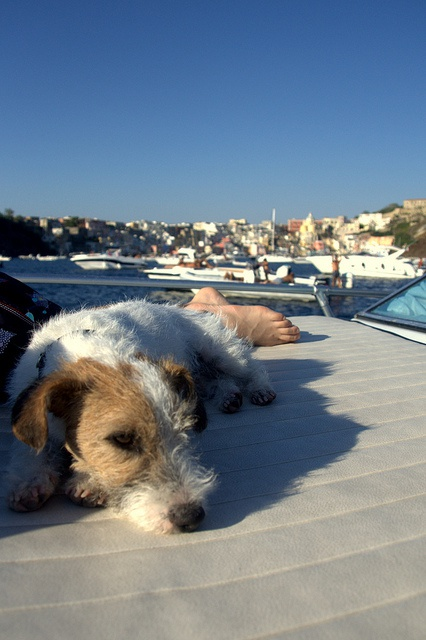Describe the objects in this image and their specific colors. I can see dog in blue, black, gray, darkgray, and tan tones, people in blue, black, tan, and gray tones, boat in blue, beige, darkgray, and gray tones, boat in blue, beige, darkgray, gray, and tan tones, and boat in blue, darkgray, gray, beige, and black tones in this image. 